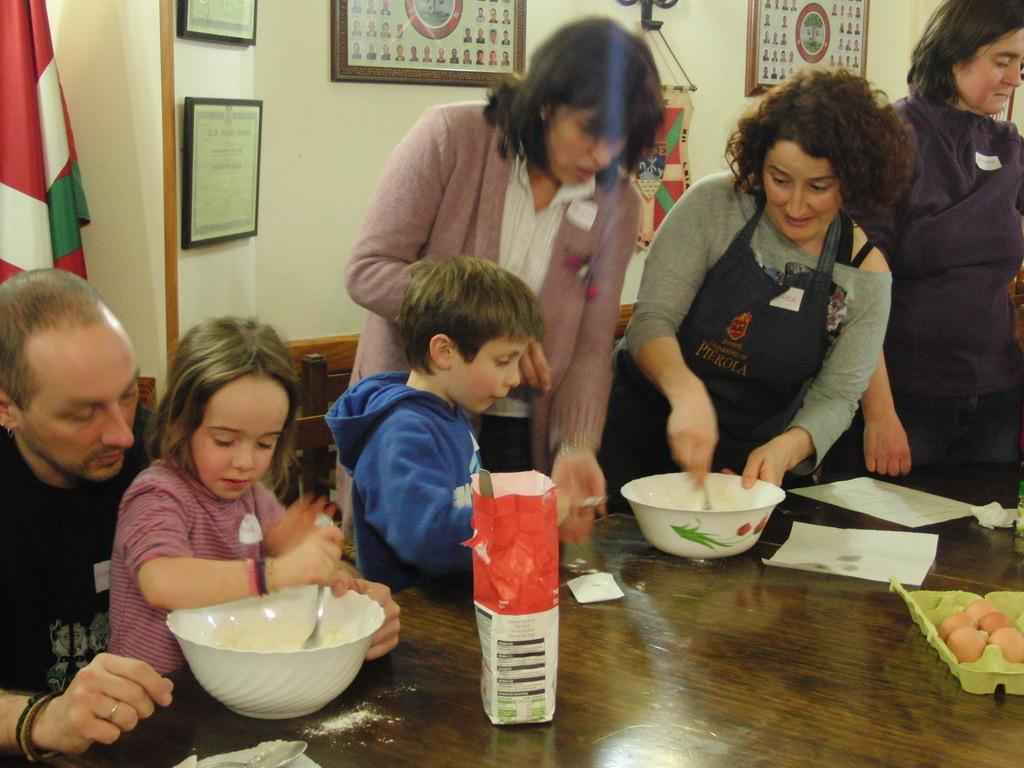What is happening in the center of the image? There are persons at the table in the center of the image. What objects are on the table with the persons? There are bowls, spoons, papers, and eggs on the table. What can be seen in the background of the image? In the background, there are photo frames, a flag, and a wall. What type of steel is used to construct the sky in the image? There is no steel or sky present in the image; it features a table with persons and objects, as well as a background with photo frames, a flag, and a wall. 